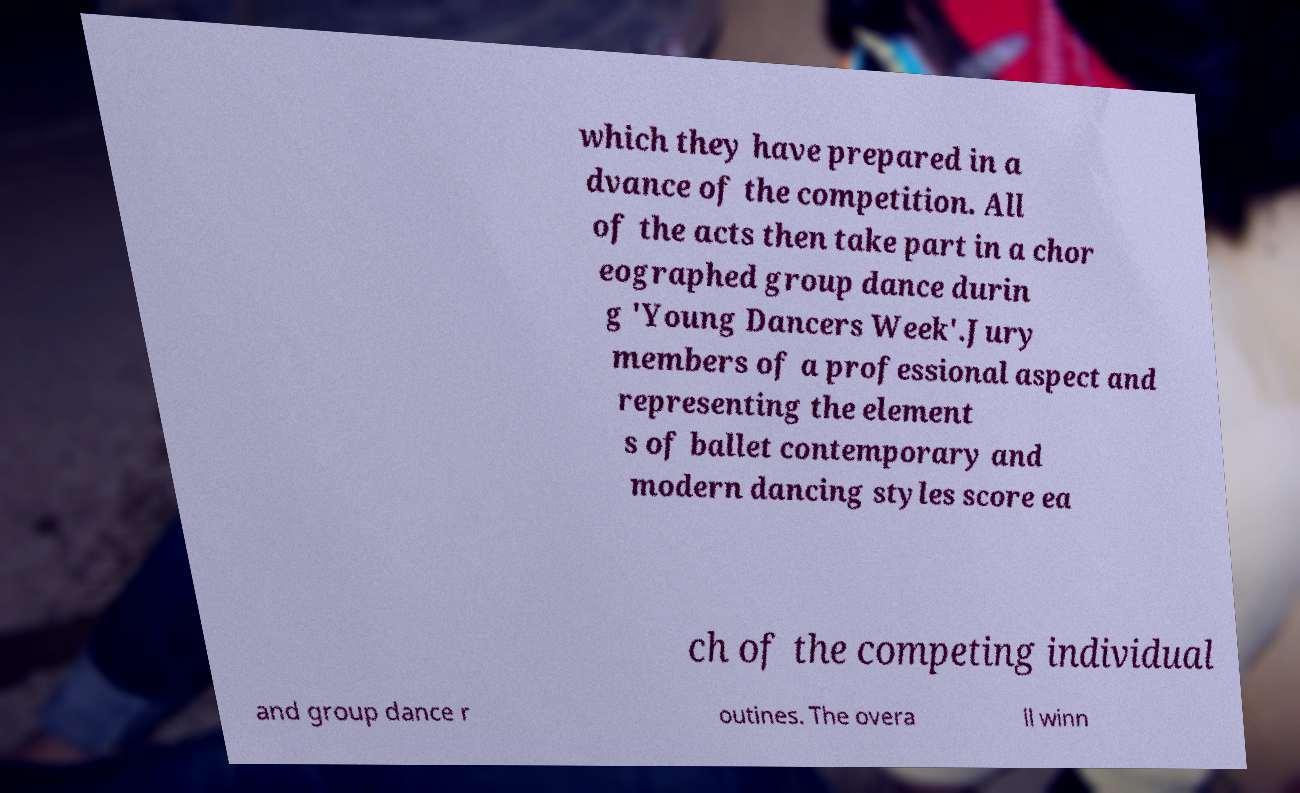Can you read and provide the text displayed in the image?This photo seems to have some interesting text. Can you extract and type it out for me? which they have prepared in a dvance of the competition. All of the acts then take part in a chor eographed group dance durin g 'Young Dancers Week'.Jury members of a professional aspect and representing the element s of ballet contemporary and modern dancing styles score ea ch of the competing individual and group dance r outines. The overa ll winn 